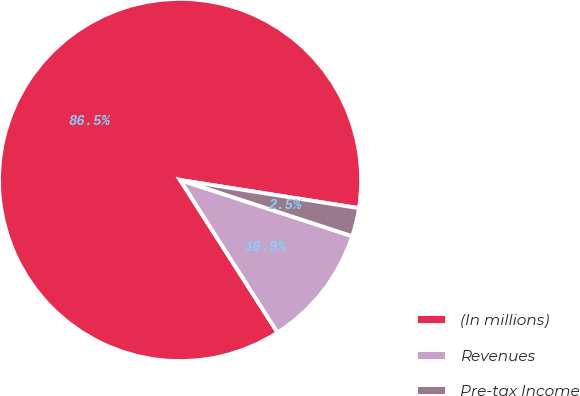Convert chart. <chart><loc_0><loc_0><loc_500><loc_500><pie_chart><fcel>(In millions)<fcel>Revenues<fcel>Pre-tax Income<nl><fcel>86.53%<fcel>10.93%<fcel>2.54%<nl></chart> 